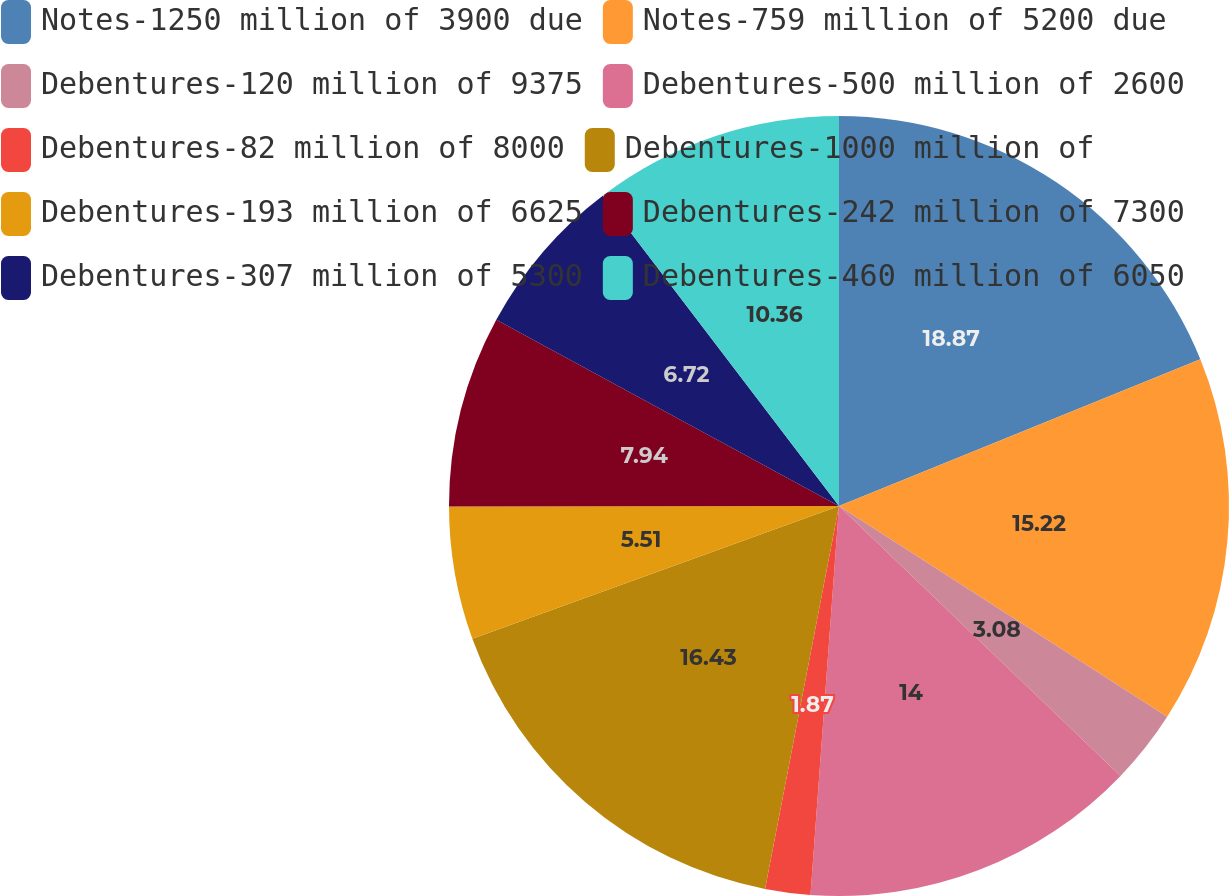Convert chart. <chart><loc_0><loc_0><loc_500><loc_500><pie_chart><fcel>Notes-1250 million of 3900 due<fcel>Notes-759 million of 5200 due<fcel>Debentures-120 million of 9375<fcel>Debentures-500 million of 2600<fcel>Debentures-82 million of 8000<fcel>Debentures-1000 million of<fcel>Debentures-193 million of 6625<fcel>Debentures-242 million of 7300<fcel>Debentures-307 million of 5300<fcel>Debentures-460 million of 6050<nl><fcel>18.86%<fcel>15.22%<fcel>3.08%<fcel>14.0%<fcel>1.87%<fcel>16.43%<fcel>5.51%<fcel>7.94%<fcel>6.72%<fcel>10.36%<nl></chart> 